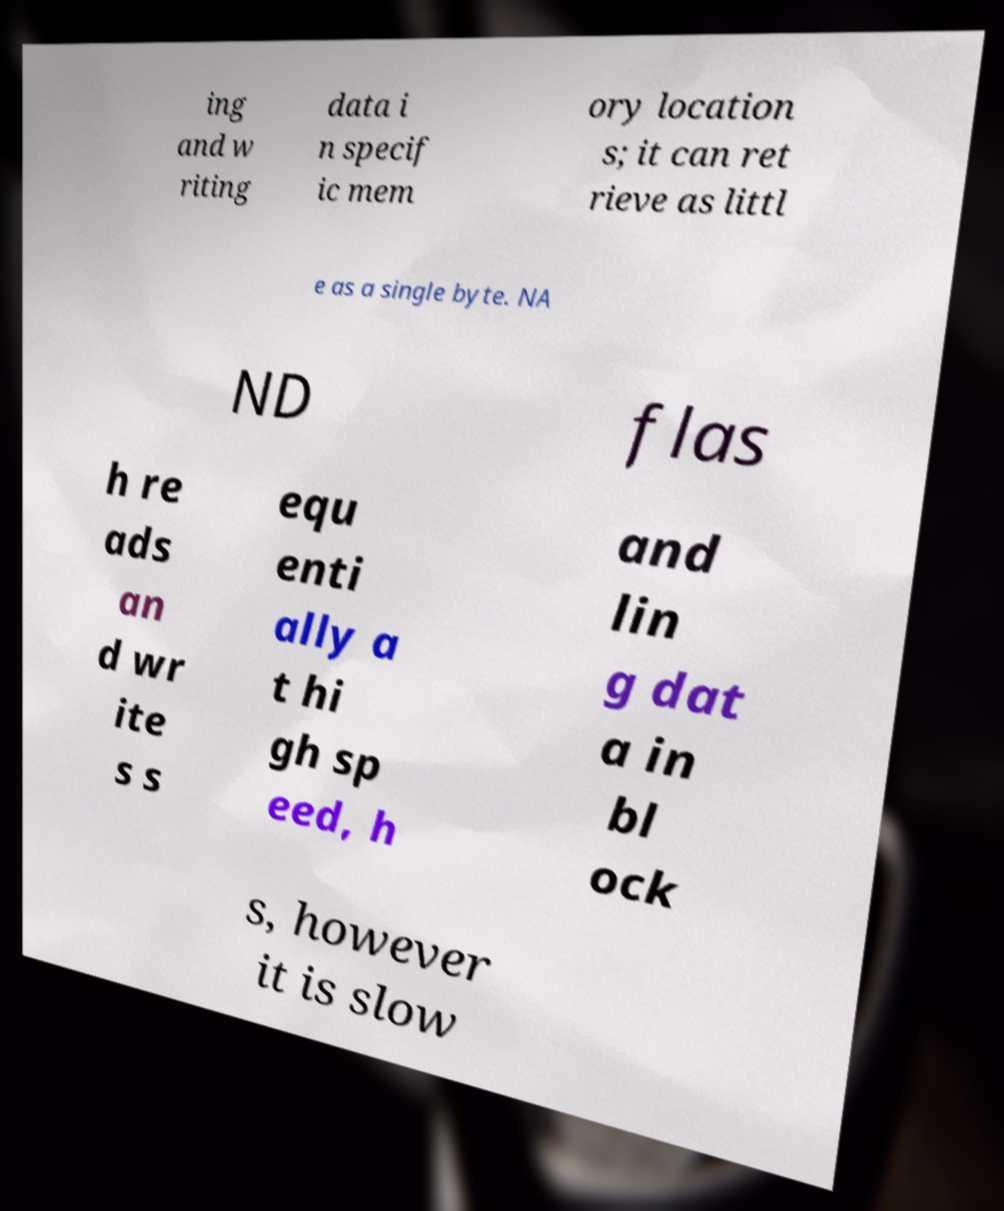Could you extract and type out the text from this image? ing and w riting data i n specif ic mem ory location s; it can ret rieve as littl e as a single byte. NA ND flas h re ads an d wr ite s s equ enti ally a t hi gh sp eed, h and lin g dat a in bl ock s, however it is slow 